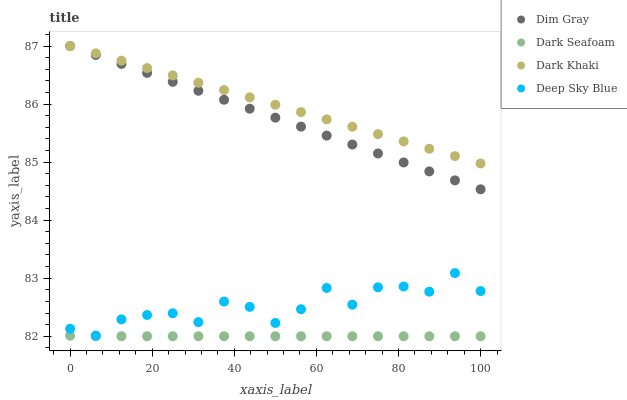Does Dark Seafoam have the minimum area under the curve?
Answer yes or no. Yes. Does Dark Khaki have the maximum area under the curve?
Answer yes or no. Yes. Does Dim Gray have the minimum area under the curve?
Answer yes or no. No. Does Dim Gray have the maximum area under the curve?
Answer yes or no. No. Is Dark Khaki the smoothest?
Answer yes or no. Yes. Is Deep Sky Blue the roughest?
Answer yes or no. Yes. Is Dark Seafoam the smoothest?
Answer yes or no. No. Is Dark Seafoam the roughest?
Answer yes or no. No. Does Dark Seafoam have the lowest value?
Answer yes or no. Yes. Does Dim Gray have the lowest value?
Answer yes or no. No. Does Dim Gray have the highest value?
Answer yes or no. Yes. Does Dark Seafoam have the highest value?
Answer yes or no. No. Is Deep Sky Blue less than Dark Khaki?
Answer yes or no. Yes. Is Dim Gray greater than Dark Seafoam?
Answer yes or no. Yes. Does Dim Gray intersect Dark Khaki?
Answer yes or no. Yes. Is Dim Gray less than Dark Khaki?
Answer yes or no. No. Is Dim Gray greater than Dark Khaki?
Answer yes or no. No. Does Deep Sky Blue intersect Dark Khaki?
Answer yes or no. No. 